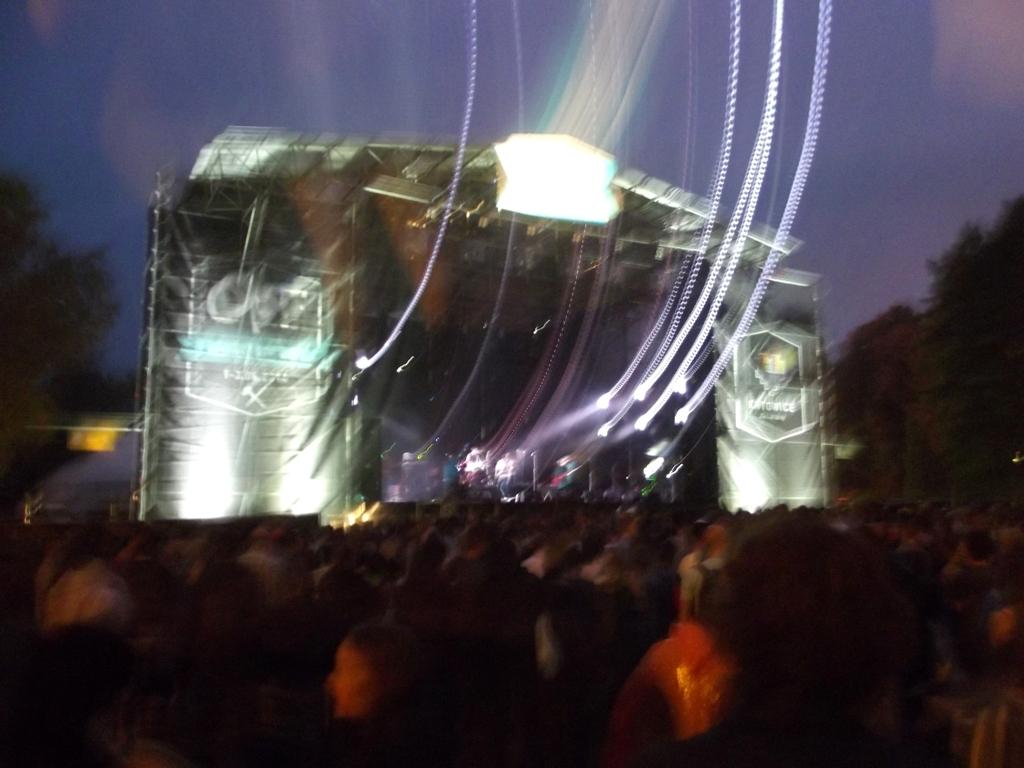What is the main subject of the image? There is a person performing on a dais in the image. What can be seen at the bottom of the image? There is a crowd at the bottom of the image. What is visible in the background of the image? Trees, stage lighting, and the sky are visible in the background of the image. Can you tell me how many kites are being flown by the crowd in the image? There are no kites visible in the image; the crowd is watching the person performing on the dais. What type of hate is being expressed by the person performing on the dais? There is no indication of hate being expressed in the image; the person is performing, and the crowd is watching. 